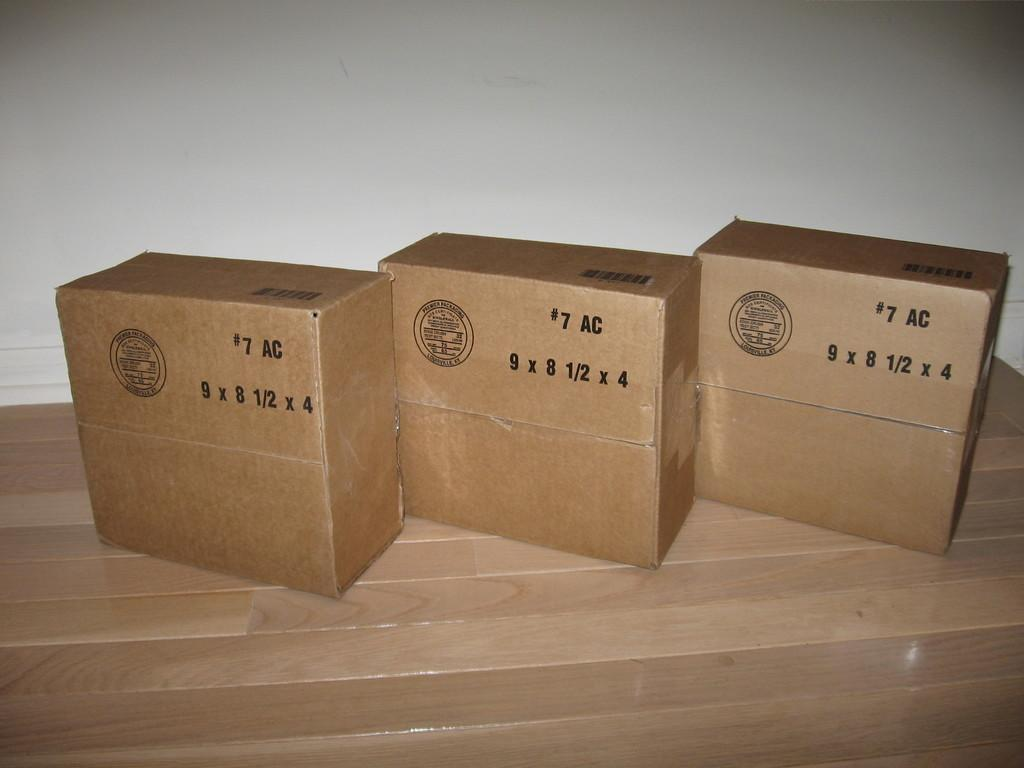<image>
Provide a brief description of the given image. Three boxes on a table, all of which have 7 AC written at the top 